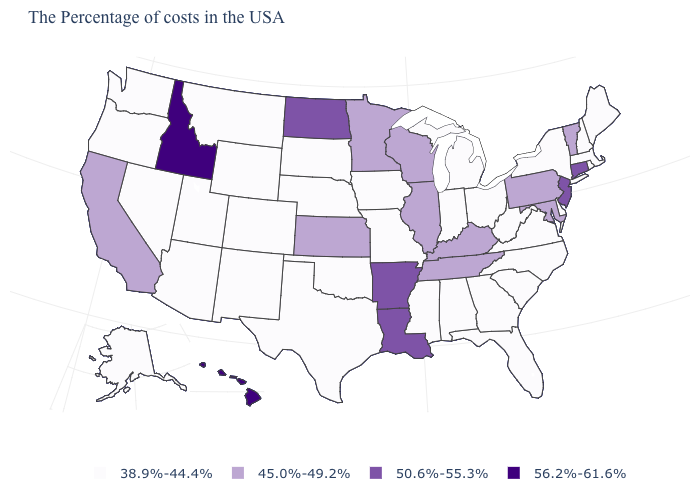What is the value of Missouri?
Short answer required. 38.9%-44.4%. What is the value of Utah?
Give a very brief answer. 38.9%-44.4%. What is the value of Ohio?
Short answer required. 38.9%-44.4%. Name the states that have a value in the range 38.9%-44.4%?
Short answer required. Maine, Massachusetts, Rhode Island, New Hampshire, New York, Delaware, Virginia, North Carolina, South Carolina, West Virginia, Ohio, Florida, Georgia, Michigan, Indiana, Alabama, Mississippi, Missouri, Iowa, Nebraska, Oklahoma, Texas, South Dakota, Wyoming, Colorado, New Mexico, Utah, Montana, Arizona, Nevada, Washington, Oregon, Alaska. Does Minnesota have the lowest value in the MidWest?
Be succinct. No. Name the states that have a value in the range 56.2%-61.6%?
Concise answer only. Idaho, Hawaii. Name the states that have a value in the range 45.0%-49.2%?
Quick response, please. Vermont, Maryland, Pennsylvania, Kentucky, Tennessee, Wisconsin, Illinois, Minnesota, Kansas, California. Is the legend a continuous bar?
Be succinct. No. Name the states that have a value in the range 45.0%-49.2%?
Keep it brief. Vermont, Maryland, Pennsylvania, Kentucky, Tennessee, Wisconsin, Illinois, Minnesota, Kansas, California. Which states have the lowest value in the West?
Concise answer only. Wyoming, Colorado, New Mexico, Utah, Montana, Arizona, Nevada, Washington, Oregon, Alaska. Does the first symbol in the legend represent the smallest category?
Give a very brief answer. Yes. Does California have the lowest value in the USA?
Give a very brief answer. No. What is the value of Indiana?
Be succinct. 38.9%-44.4%. Among the states that border Tennessee , does Arkansas have the lowest value?
Quick response, please. No. What is the highest value in the South ?
Be succinct. 50.6%-55.3%. 